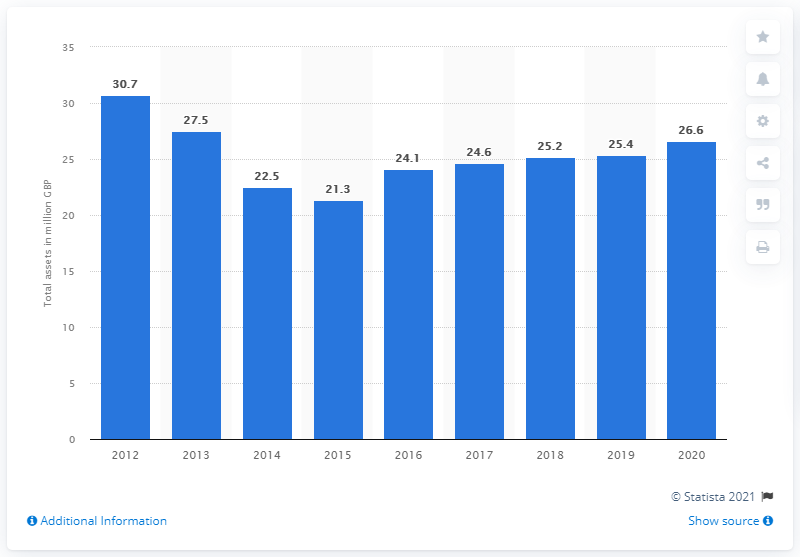Mention a couple of crucial points in this snapshot. Ulster Bank had total assets of approximately 26.6 billion euros in 2020. 